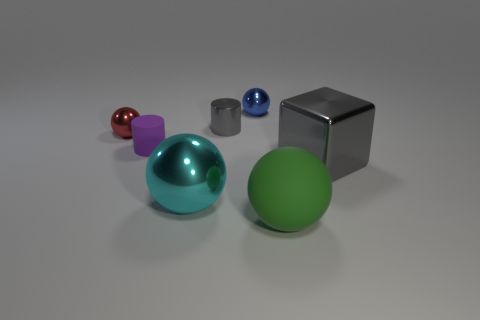Is the color of the big shiny block the same as the metallic cylinder?
Make the answer very short. Yes. There is a large sphere on the right side of the large metallic object on the left side of the small cylinder that is behind the tiny purple rubber cylinder; what is its material?
Provide a short and direct response. Rubber. There is a rubber sphere; are there any big cyan objects in front of it?
Offer a terse response. No. There is a gray object that is the same size as the cyan metallic ball; what is its shape?
Offer a very short reply. Cube. Do the gray cylinder and the small purple thing have the same material?
Keep it short and to the point. No. What number of shiny things are large things or big cubes?
Keep it short and to the point. 2. What is the shape of the thing that is the same color as the small shiny cylinder?
Offer a very short reply. Cube. There is a large thing behind the big cyan object; is its color the same as the metal cylinder?
Provide a short and direct response. Yes. There is a matte object that is to the left of the large thing left of the small blue metallic thing; what shape is it?
Make the answer very short. Cylinder. What number of things are metal objects that are left of the gray metallic cube or shiny spheres that are in front of the shiny block?
Make the answer very short. 4. 